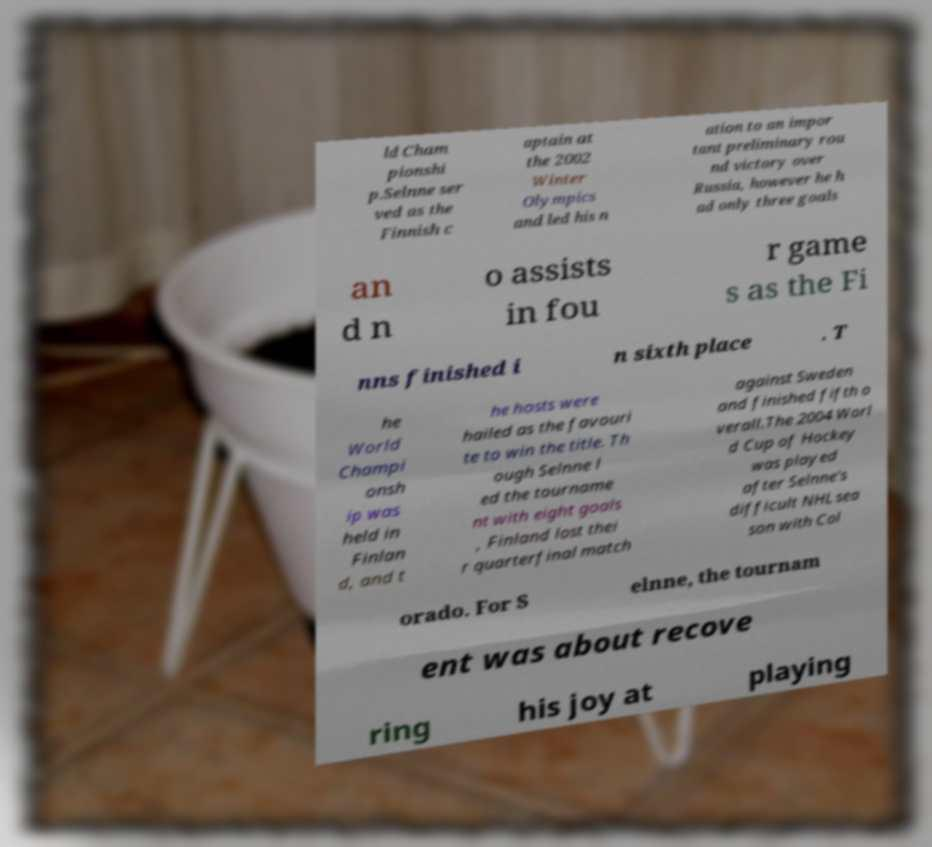Please read and relay the text visible in this image. What does it say? ld Cham pionshi p.Selnne ser ved as the Finnish c aptain at the 2002 Winter Olympics and led his n ation to an impor tant preliminary rou nd victory over Russia, however he h ad only three goals an d n o assists in fou r game s as the Fi nns finished i n sixth place . T he World Champi onsh ip was held in Finlan d, and t he hosts were hailed as the favouri te to win the title. Th ough Selnne l ed the tourname nt with eight goals , Finland lost thei r quarterfinal match against Sweden and finished fifth o verall.The 2004 Worl d Cup of Hockey was played after Selnne's difficult NHL sea son with Col orado. For S elnne, the tournam ent was about recove ring his joy at playing 